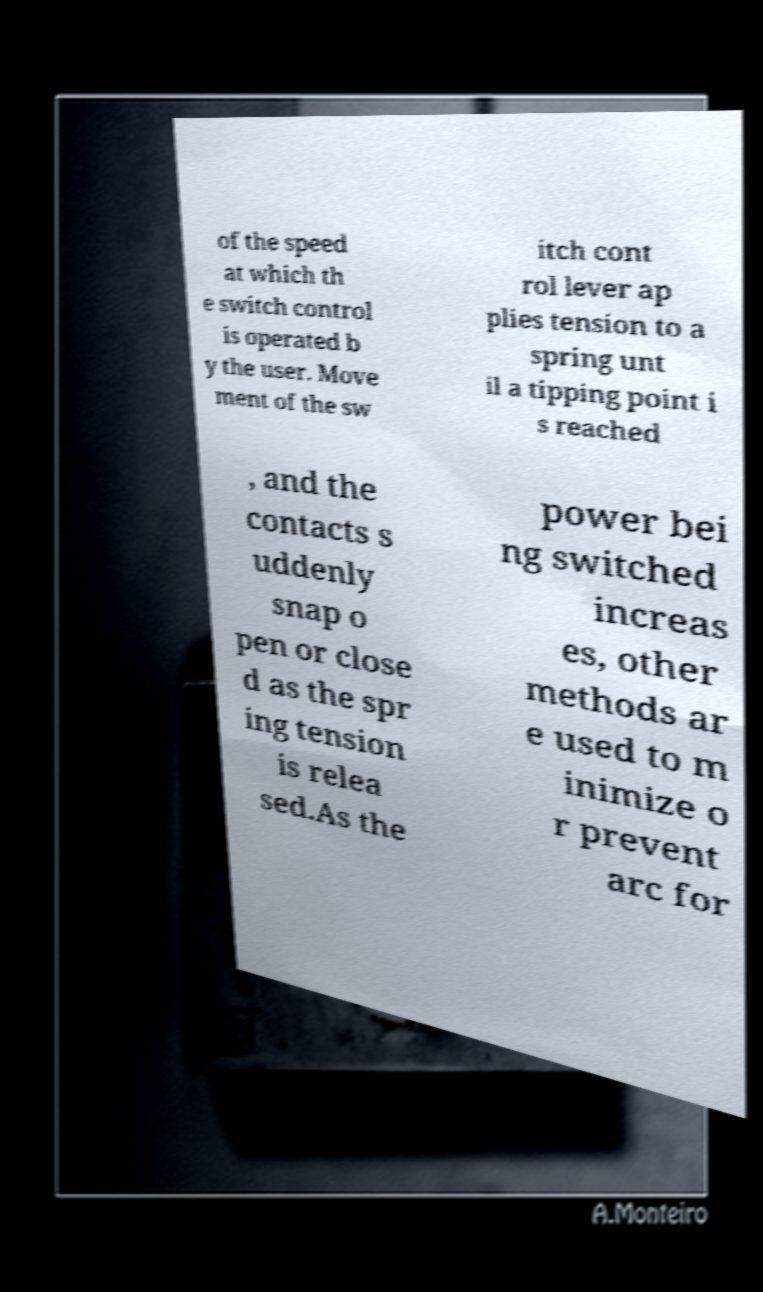Please read and relay the text visible in this image. What does it say? of the speed at which th e switch control is operated b y the user. Move ment of the sw itch cont rol lever ap plies tension to a spring unt il a tipping point i s reached , and the contacts s uddenly snap o pen or close d as the spr ing tension is relea sed.As the power bei ng switched increas es, other methods ar e used to m inimize o r prevent arc for 